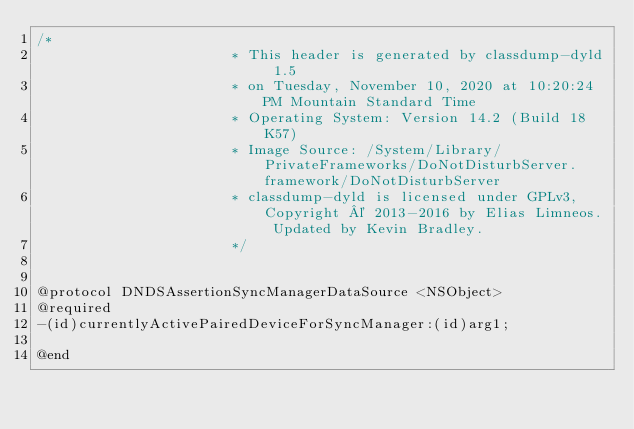<code> <loc_0><loc_0><loc_500><loc_500><_C_>/*
                       * This header is generated by classdump-dyld 1.5
                       * on Tuesday, November 10, 2020 at 10:20:24 PM Mountain Standard Time
                       * Operating System: Version 14.2 (Build 18K57)
                       * Image Source: /System/Library/PrivateFrameworks/DoNotDisturbServer.framework/DoNotDisturbServer
                       * classdump-dyld is licensed under GPLv3, Copyright © 2013-2016 by Elias Limneos. Updated by Kevin Bradley.
                       */


@protocol DNDSAssertionSyncManagerDataSource <NSObject>
@required
-(id)currentlyActivePairedDeviceForSyncManager:(id)arg1;

@end

</code> 